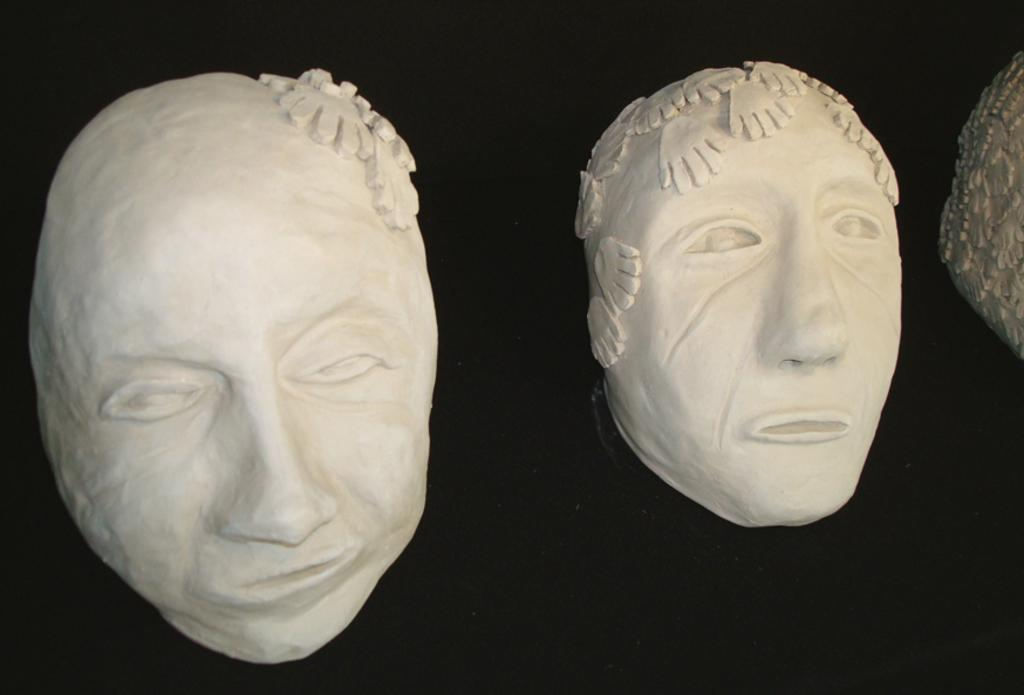What is the main subject in the center of the image? There are sculptures of faces in the center of the image. What can be seen in the right corner of the image? There is an object in the right corner of the image. What is the color of the background in the image? The background of the image is black in color. What type of soap is being used by the writer in the image? There is no soap or writer present in the image; it features sculptures of faces and a black background. What kind of brush is being used by the artist in the image? There is no artist or brush present in the image; it features sculptures of faces and a black background. 